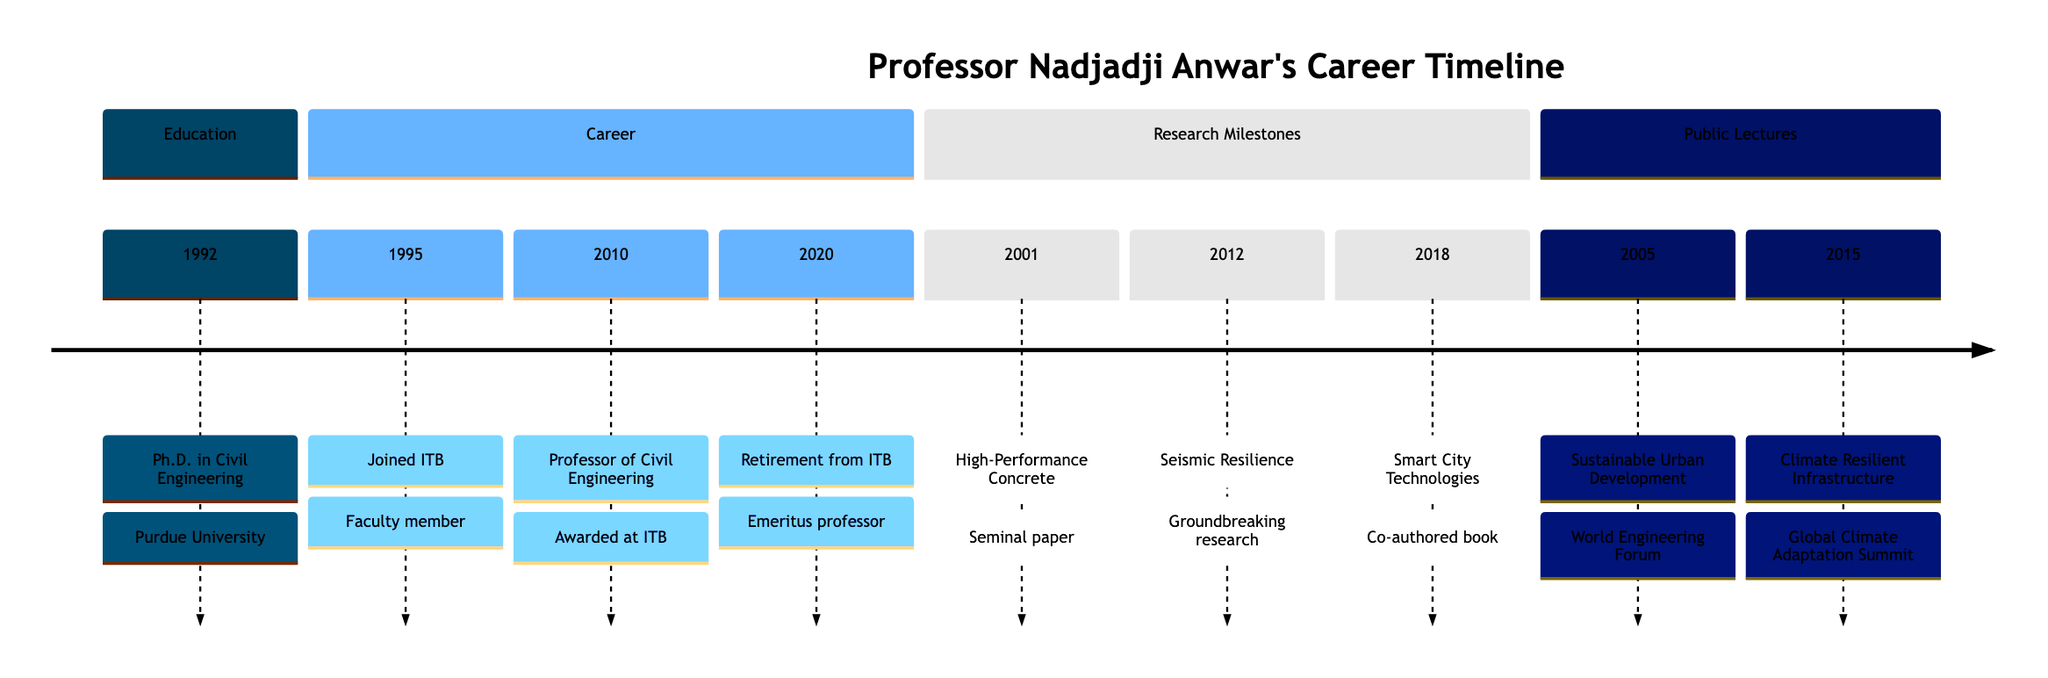What year did Professor Nadjadji Anwar receive his Ph.D.? The timeline indicates a specific event in 1992 related to receiving a doctoral degree, which is labeled "Ph.D. in Civil Engineering" from Purdue University.
Answer: 1992 What significant research was published in 2001? In 2001, the timeline highlights an important research contribution labeled "Research on High-Performance Concrete," which notes that a seminal paper was published.
Answer: High-Performance Concrete How many public lectures are listed in the timeline? By counting the events in the "Public Lectures" section, there are two specific events related to lectures: one in 2005 and another in 2015.
Answer: 2 In which year did Professor Anwar conduct groundbreaking research on seismic resilience? The timeline shows that research on seismic resilience occurred in 2012, as indicated by a specific entry in the "Research Milestones" section.
Answer: 2012 What title was awarded to Professor Anwar in 2010? The timeline specifically mentions that in 2010, Professor Anwar was awarded the title of "Professor of Civil Engineering" at ITB for his contributions, as detailed in the "Career" section.
Answer: Professor of Civil Engineering What was the focus of the public lecture delivered in 2005? The timeline entry for 2005 states that the lecture was on "Sustainable Urban Development," emphasizing the related theme at the World Engineering Forum.
Answer: Sustainable Urban Development Which research topic was co-authored into a book in 2018? The timeline mentions an event in 2018 where Professor Anwar co-authored a book on "Smart City Technologies," indicating its relevance in urban planning as noted in the "Research Milestones" section.
Answer: Smart City Technologies What does the title for the year 2020 indicate? In the timeline for 2020, it is specifically mentioned that Professor Anwar retired from ITB and continued as an emeritus professor and consultant, providing a clear summary of his status.
Answer: Retirement from ITB 